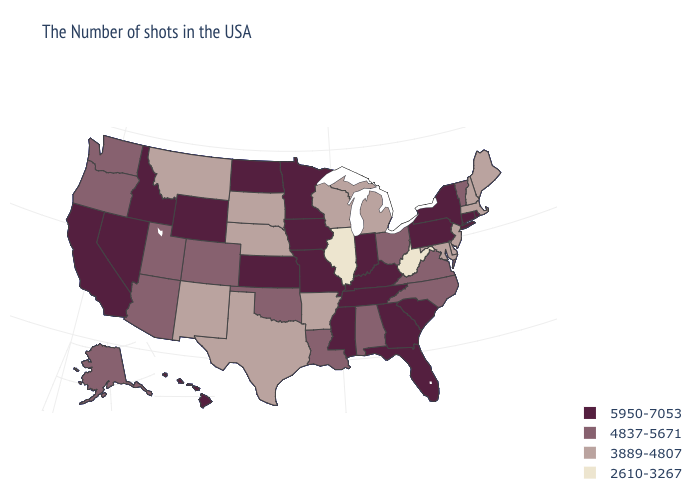What is the highest value in the Northeast ?
Be succinct. 5950-7053. Among the states that border North Carolina , which have the lowest value?
Be succinct. Virginia. Does New York have the lowest value in the Northeast?
Write a very short answer. No. What is the lowest value in states that border Montana?
Be succinct. 3889-4807. Which states hav the highest value in the Northeast?
Write a very short answer. Rhode Island, Connecticut, New York, Pennsylvania. Is the legend a continuous bar?
Write a very short answer. No. Does Colorado have the same value as Oregon?
Give a very brief answer. Yes. What is the lowest value in states that border Kansas?
Write a very short answer. 3889-4807. Which states have the lowest value in the MidWest?
Quick response, please. Illinois. What is the value of Montana?
Write a very short answer. 3889-4807. What is the highest value in states that border Tennessee?
Be succinct. 5950-7053. Which states hav the highest value in the West?
Quick response, please. Wyoming, Idaho, Nevada, California, Hawaii. Which states have the highest value in the USA?
Give a very brief answer. Rhode Island, Connecticut, New York, Pennsylvania, South Carolina, Florida, Georgia, Kentucky, Indiana, Tennessee, Mississippi, Missouri, Minnesota, Iowa, Kansas, North Dakota, Wyoming, Idaho, Nevada, California, Hawaii. What is the highest value in the MidWest ?
Keep it brief. 5950-7053. 